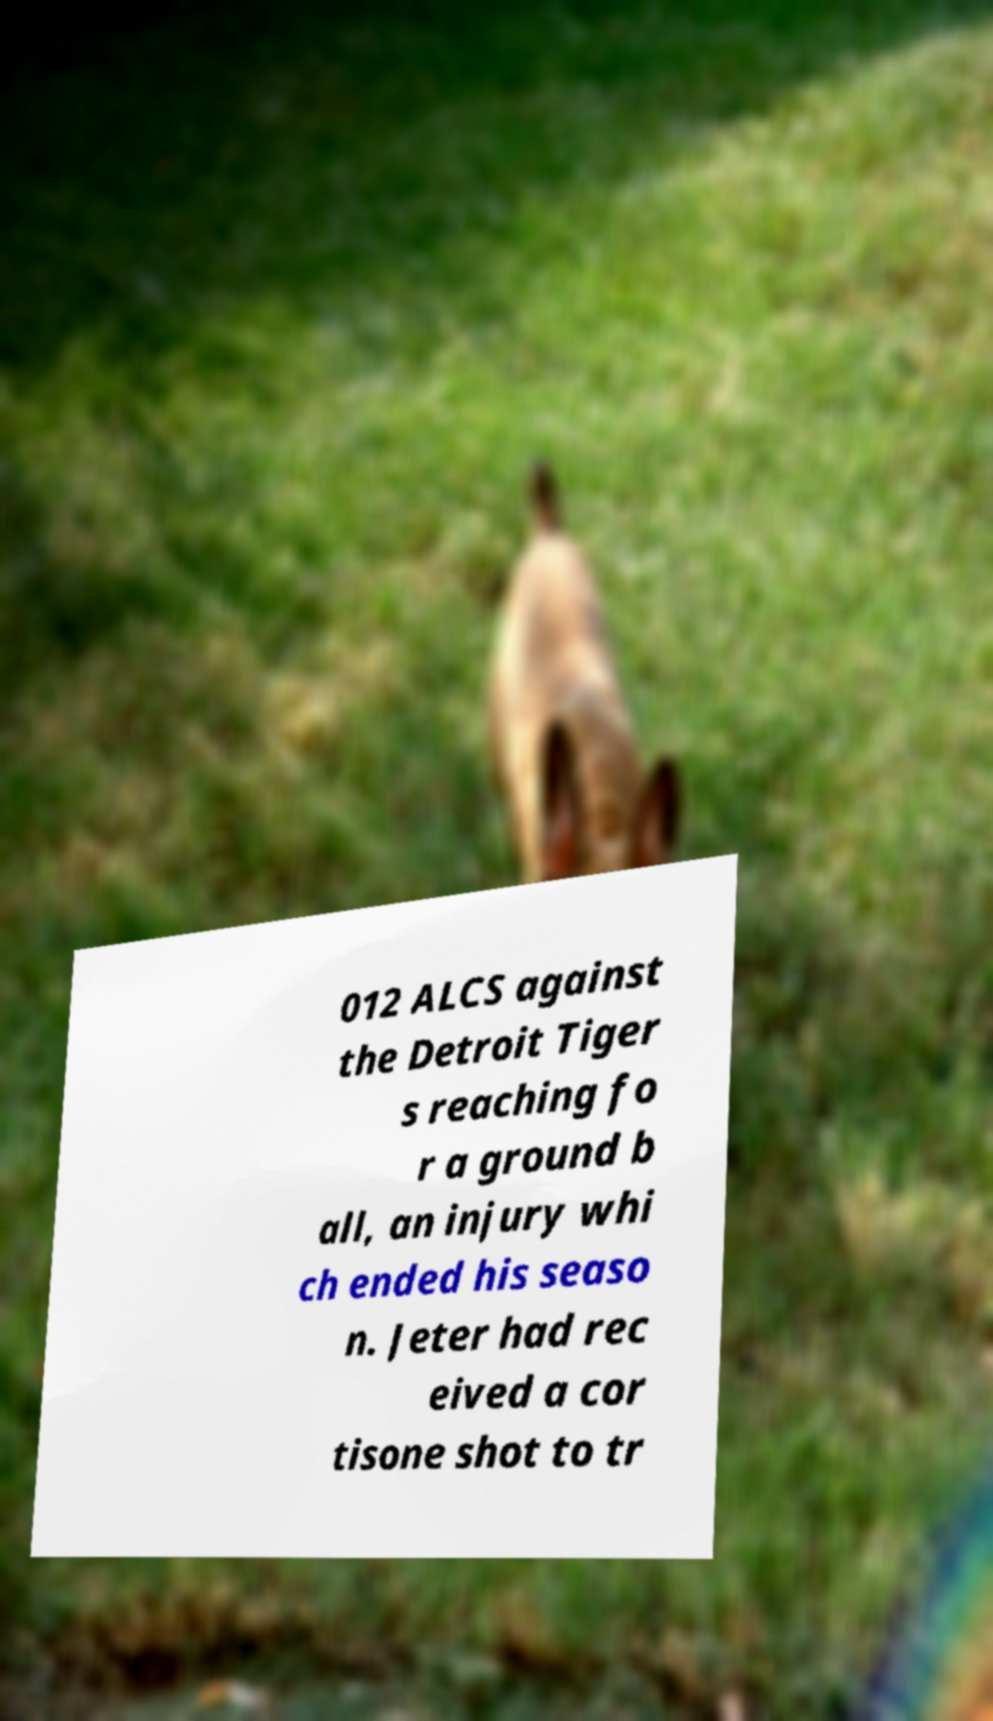Can you read and provide the text displayed in the image?This photo seems to have some interesting text. Can you extract and type it out for me? 012 ALCS against the Detroit Tiger s reaching fo r a ground b all, an injury whi ch ended his seaso n. Jeter had rec eived a cor tisone shot to tr 